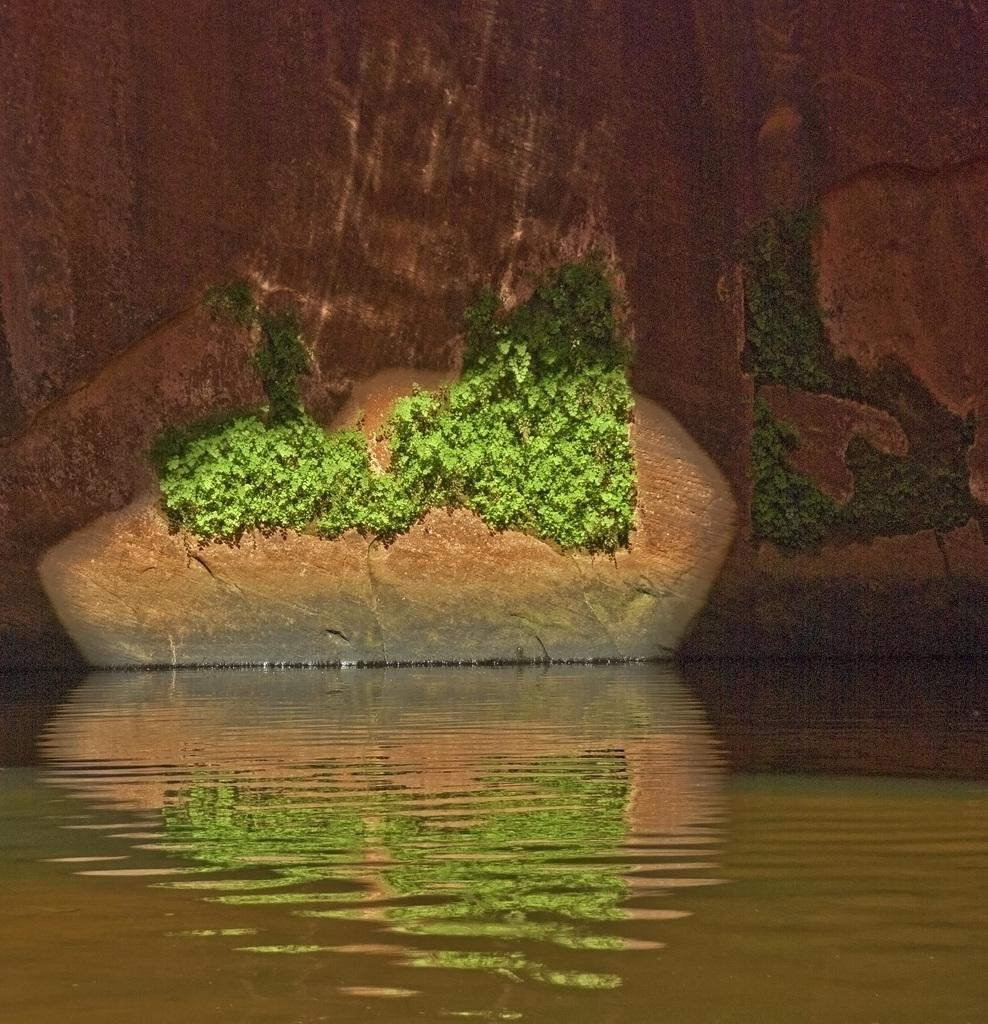What type of vegetation is growing on the wall in the image? There are creepers on the wall in the image. What can be seen in addition to the creepers on the wall? Water is visible in the image. What type of boot is being worn by the neck in the image? There is no boot or neck present in the image; it only features creepers on the wall and water. 